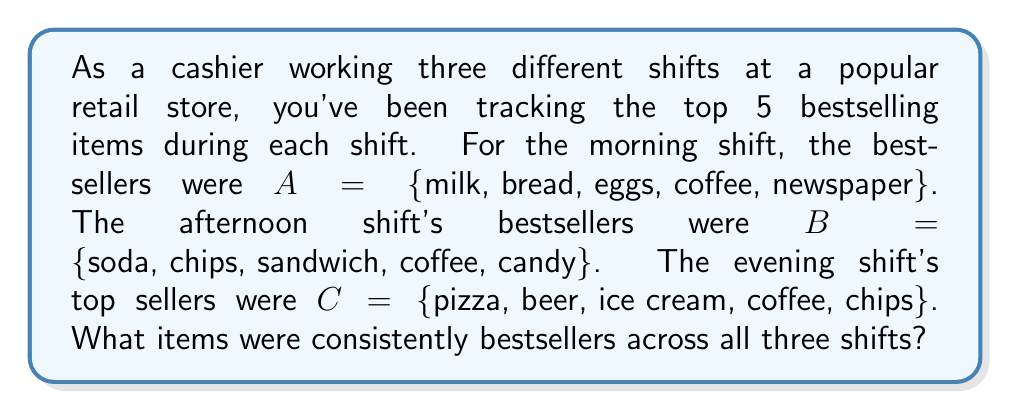What is the answer to this math problem? To solve this problem, we need to find the intersection of sets A, B, and C. The intersection of sets contains elements that are common to all the given sets.

Let's denote the intersection as $A \cap B \cap C$.

Step 1: Identify common elements between sets A and B.
$A \cap B = \{$coffee$\}$

Step 2: Identify common elements between sets B and C.
$B \cap C = \{$coffee, chips$\}$

Step 3: Find the intersection of all three sets.
$A \cap B \cap C = (A \cap B) \cap C = \{$coffee$\}$

We can see that "coffee" is the only item that appears in all three sets, making it the consistent bestseller across all shifts.
Answer: $A \cap B \cap C = \{$coffee$\}$ 